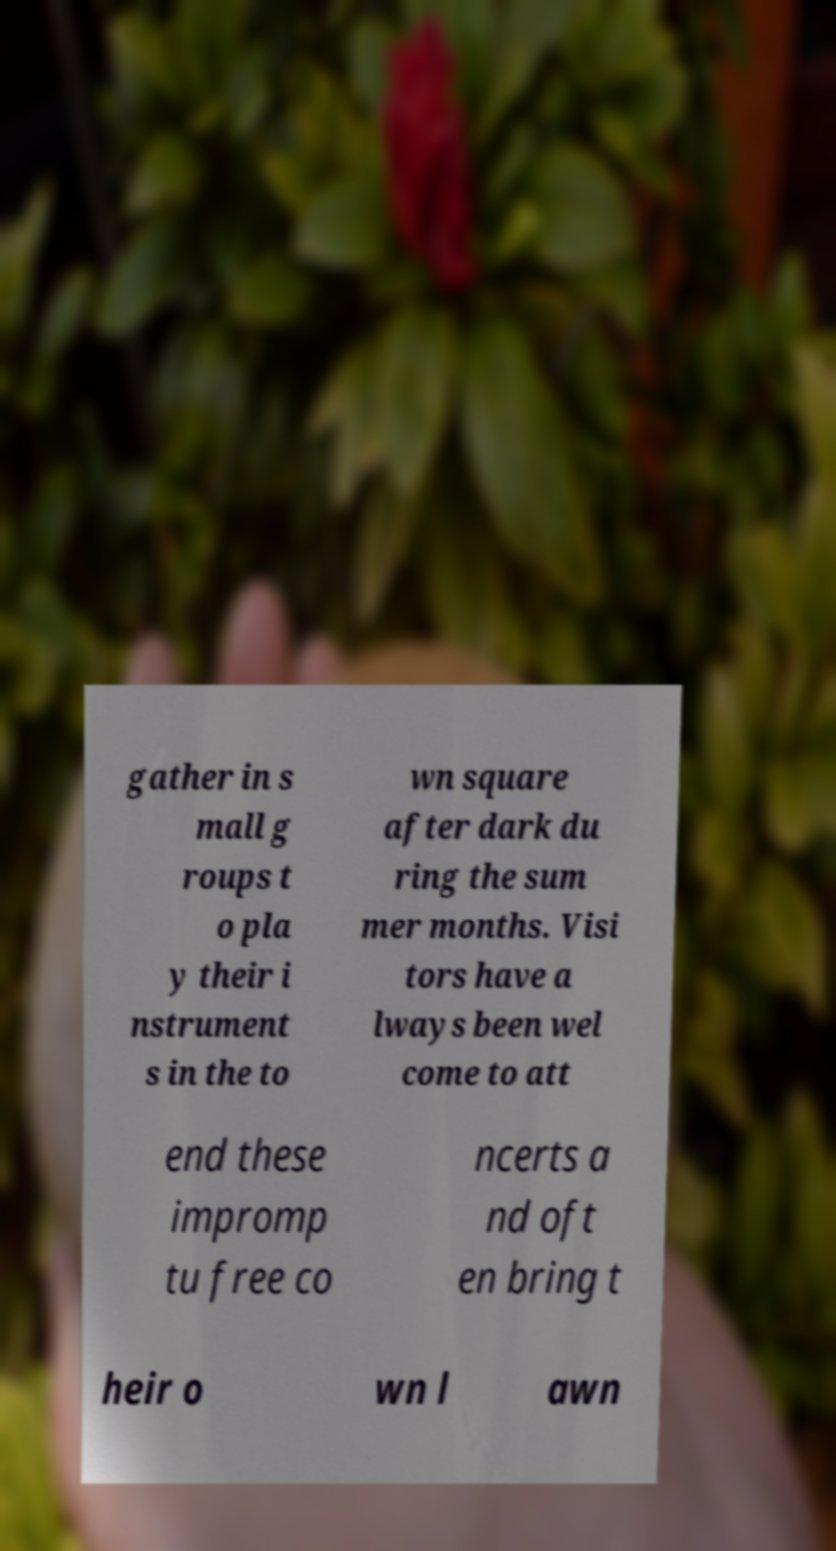What messages or text are displayed in this image? I need them in a readable, typed format. gather in s mall g roups t o pla y their i nstrument s in the to wn square after dark du ring the sum mer months. Visi tors have a lways been wel come to att end these impromp tu free co ncerts a nd oft en bring t heir o wn l awn 